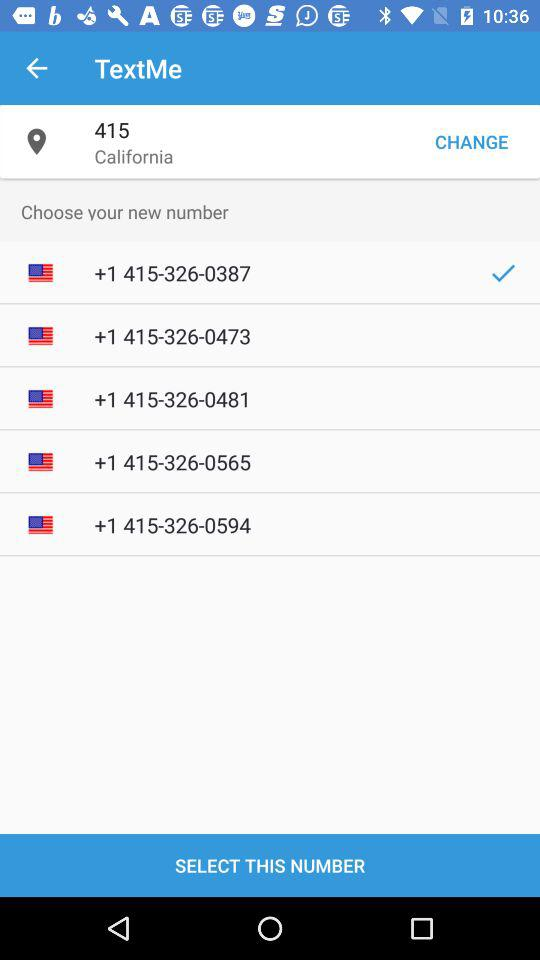Which new number is selected? The selected number is +1 415-326-0387. 